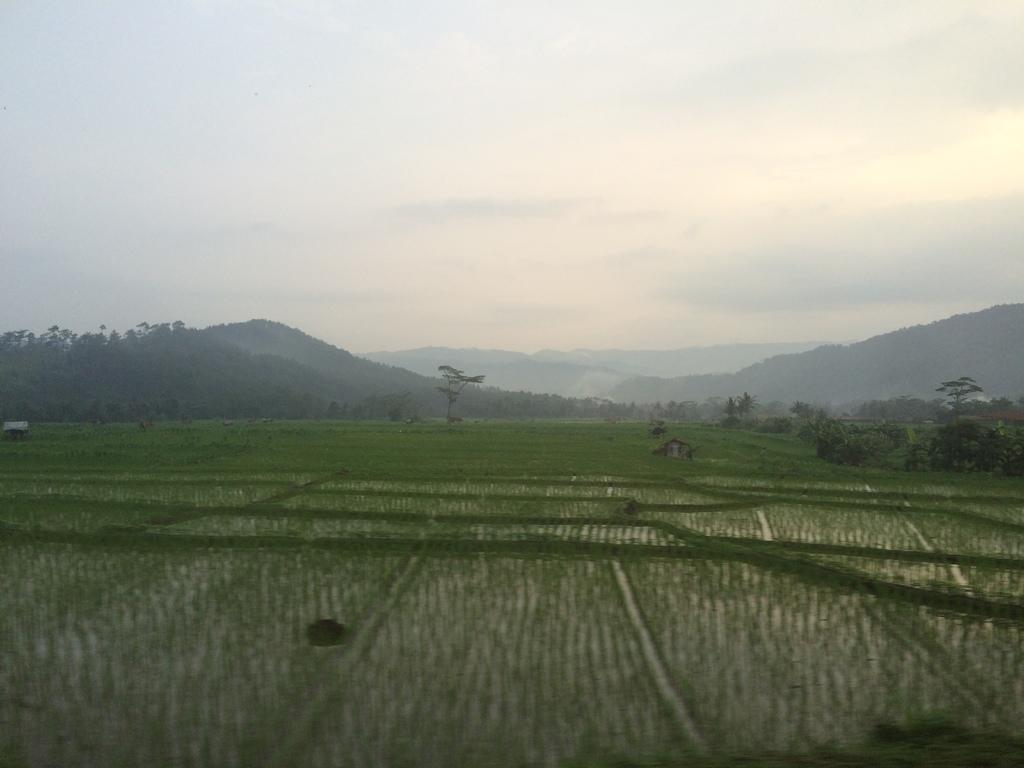What type of landscape is depicted in the image? The image features fields, trees, and mountains. Can you describe any structures in the image? There is a shed in the image. What is visible in the background of the image? The sky is visible in the background of the image, with clouds present. What type of legal advice is the lawyer providing in the image? There is no lawyer present in the image; it features a landscape with fields, trees, mountains, a shed, and a sky with clouds. 